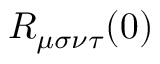Convert formula to latex. <formula><loc_0><loc_0><loc_500><loc_500>R _ { \mu \sigma \nu \tau } ( 0 )</formula> 